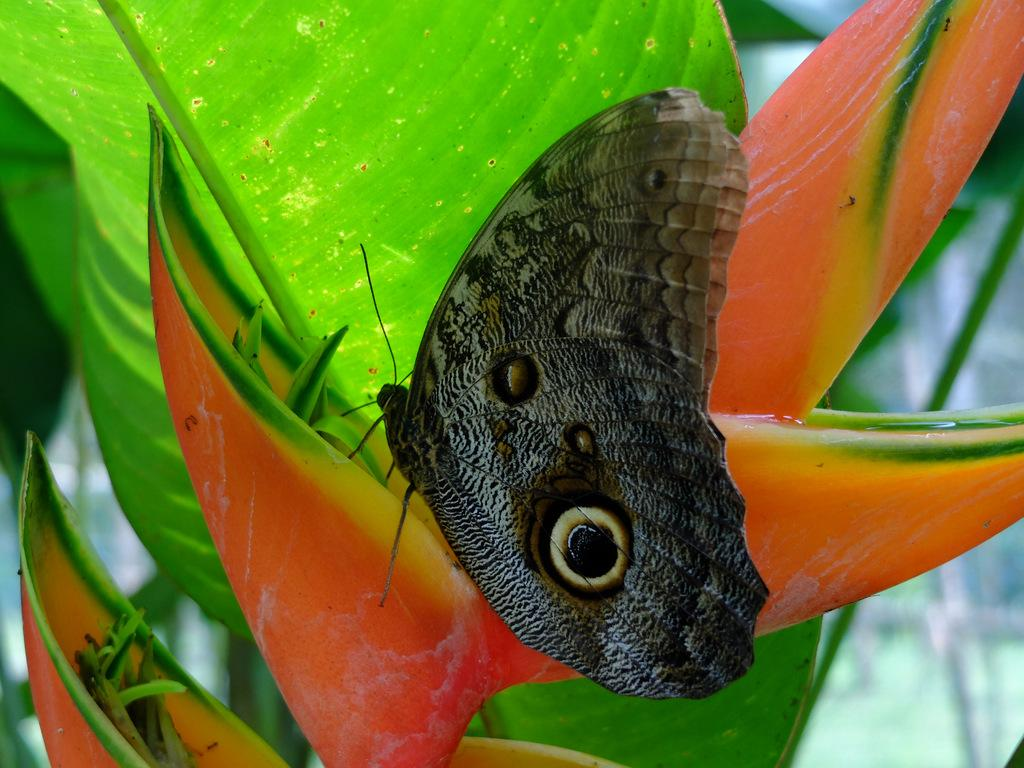What type of insect is in the image? There is a black color butterfly in the image. Where is the butterfly located? The butterfly is on a leaf. What celestial bodies can be seen in the image? There are planets visible in the image. Can you describe the background of the image? The background of the image is blurred. What type of stitch is being used to sew the shoe in the image? There is no shoe present in the image, so it is not possible to determine the type of stitch being used. 